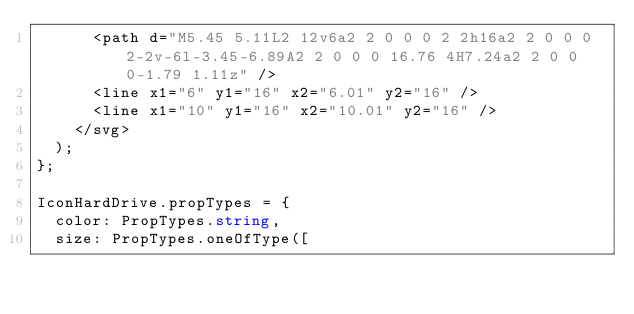Convert code to text. <code><loc_0><loc_0><loc_500><loc_500><_TypeScript_>      <path d="M5.45 5.11L2 12v6a2 2 0 0 0 2 2h16a2 2 0 0 0 2-2v-6l-3.45-6.89A2 2 0 0 0 16.76 4H7.24a2 2 0 0 0-1.79 1.11z" />
      <line x1="6" y1="16" x2="6.01" y2="16" />
      <line x1="10" y1="16" x2="10.01" y2="16" />
    </svg>
  );
};

IconHardDrive.propTypes = {
  color: PropTypes.string,
  size: PropTypes.oneOfType([</code> 